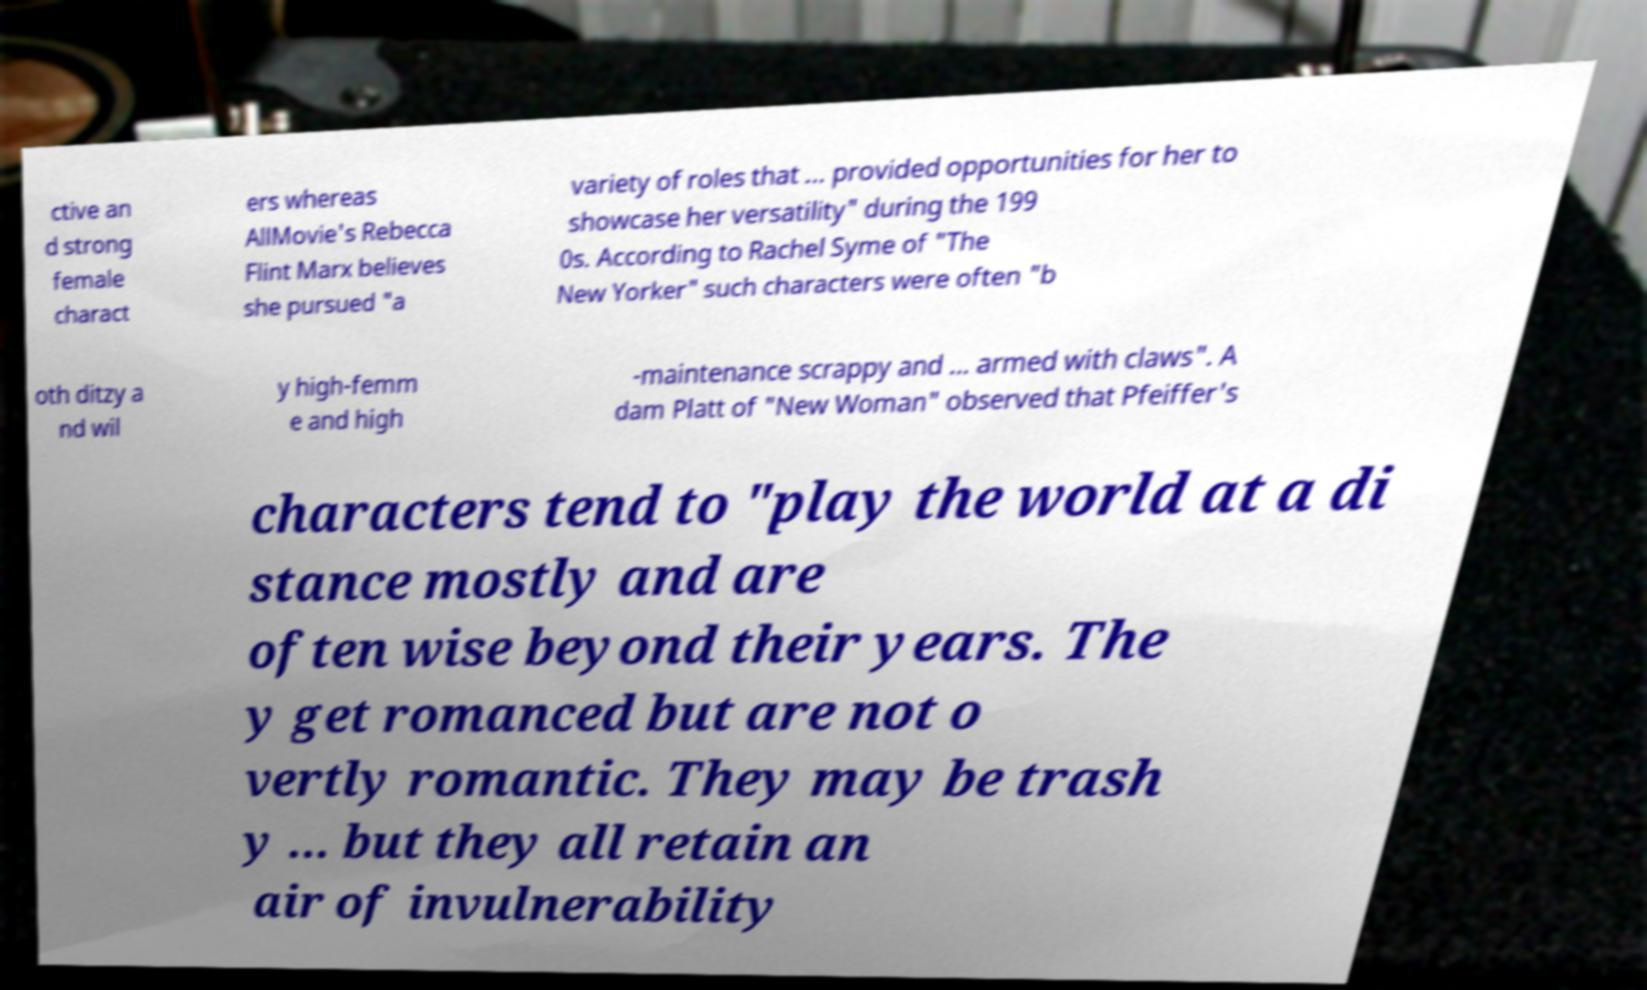Can you read and provide the text displayed in the image?This photo seems to have some interesting text. Can you extract and type it out for me? ctive an d strong female charact ers whereas AllMovie's Rebecca Flint Marx believes she pursued "a variety of roles that ... provided opportunities for her to showcase her versatility" during the 199 0s. According to Rachel Syme of "The New Yorker" such characters were often "b oth ditzy a nd wil y high-femm e and high -maintenance scrappy and ... armed with claws". A dam Platt of "New Woman" observed that Pfeiffer's characters tend to "play the world at a di stance mostly and are often wise beyond their years. The y get romanced but are not o vertly romantic. They may be trash y ... but they all retain an air of invulnerability 